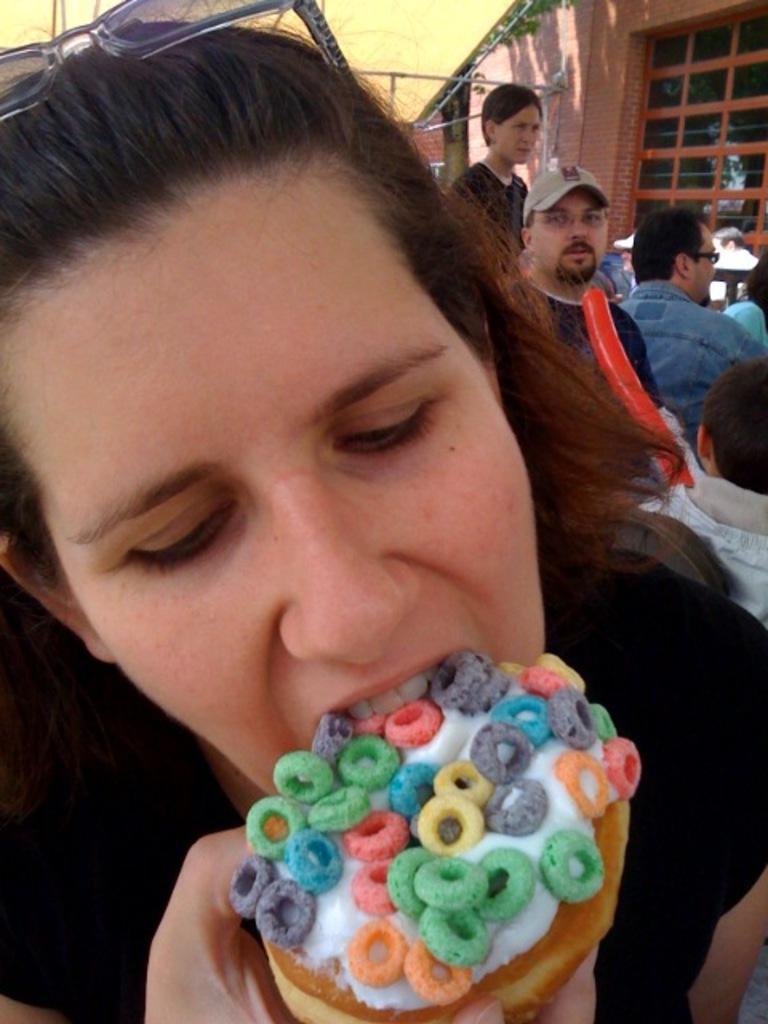Please provide a concise description of this image. In this picture we can see a person eating ice cream. Few people and a building is visible in the background. 